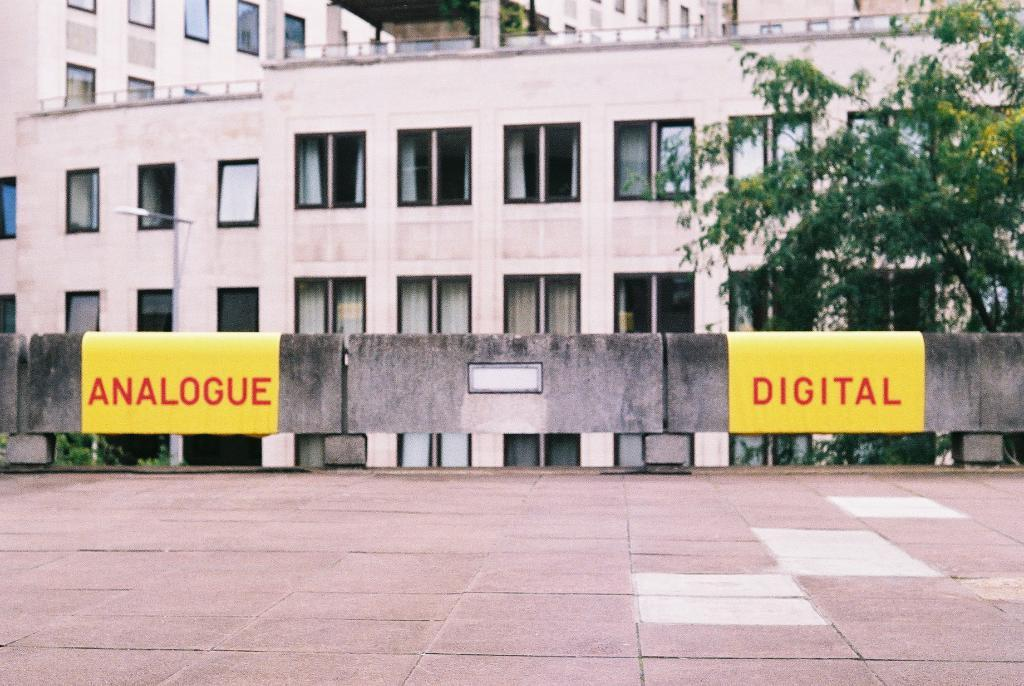What type of structures can be seen in the image? There are buildings in the image. What feature do the buildings have? The buildings have windows. Can you describe any additional items in the image? There are two yellow papers with words written on them. What can be seen in the foreground of the image? There is a path visible in the image. What type of vegetation is present in the image? There are trees in the image. Where is the kitty hiding in the image? There is no kitty present in the image. Can you see any ghosts in the image? There are no ghosts present in the image. 